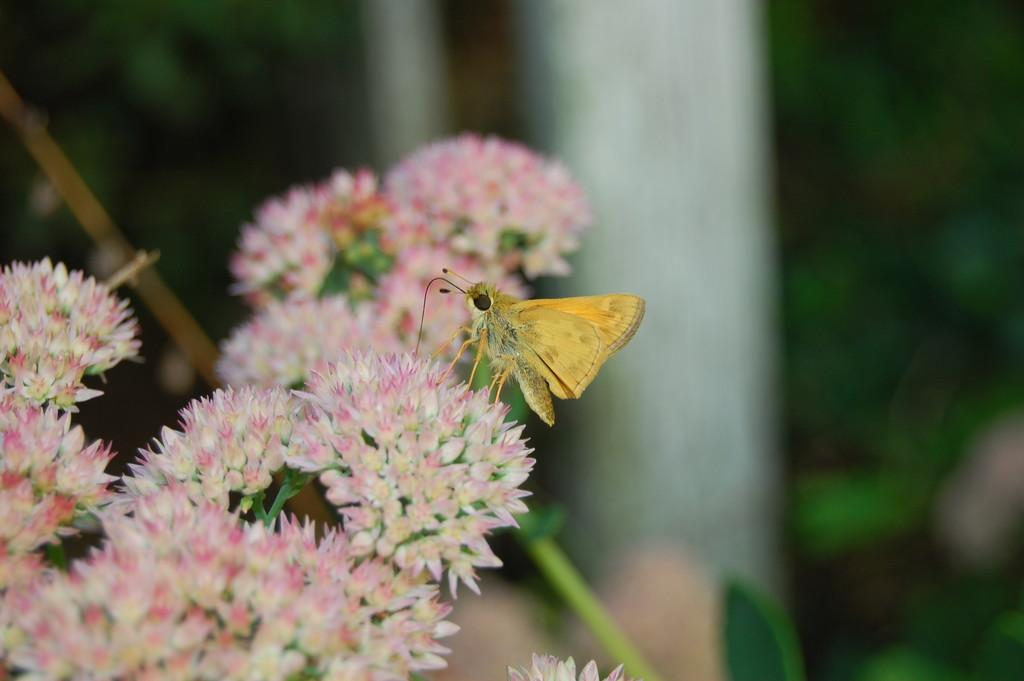What can be found on the left side of the image? There are flowers on the left side of the image. What is present on the flowers? There is a butterfly on the flowers. In which direction is the butterfly facing? The butterfly is facing towards the left side. How would you describe the background of the image? The background of the image is blurred. How does the butterfly care for the flowers in the image? The butterfly does not care for the flowers in the image; it is simply resting on them. What type of ground can be seen beneath the flowers in the image? There is no ground visible in the image; it is focused on the flowers and butterfly. 